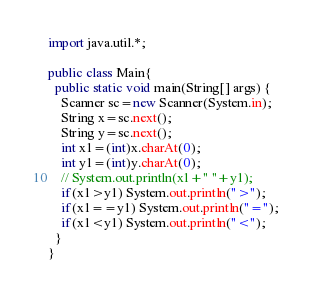<code> <loc_0><loc_0><loc_500><loc_500><_Java_>import java.util.*;

public class Main{
  public static void main(String[] args) {
    Scanner sc=new Scanner(System.in);
    String x=sc.next();
    String y=sc.next();
    int x1=(int)x.charAt(0);
    int y1=(int)y.charAt(0);
    // System.out.println(x1+" "+y1);
    if(x1>y1) System.out.println(">");
    if(x1==y1) System.out.println("=");
    if(x1<y1) System.out.println("<");
  }
}
</code> 